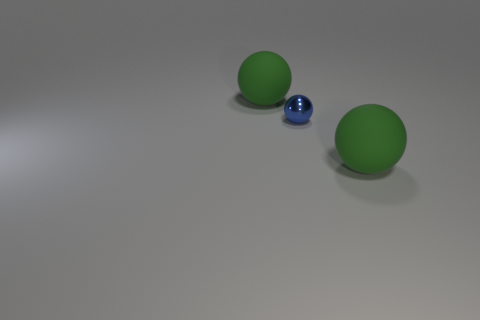Is there a big red cylinder made of the same material as the small thing?
Make the answer very short. No. What number of other objects are there of the same shape as the blue metallic object?
Your response must be concise. 2. How many objects are cyan cylinders or tiny blue spheres?
Offer a very short reply. 1. How many other things are the same size as the metallic ball?
Provide a short and direct response. 0. What number of balls are either big matte things or tiny objects?
Offer a terse response. 3. What is the tiny ball that is to the left of the green rubber ball that is in front of the small blue metal thing made of?
Your response must be concise. Metal. How many things are either big green matte balls that are on the left side of the small blue shiny sphere or tiny cyan metal blocks?
Your answer should be compact. 1. There is a blue object; is its shape the same as the matte object behind the blue thing?
Ensure brevity in your answer.  Yes. How many large green objects are behind the tiny sphere and in front of the small thing?
Provide a succinct answer. 0. There is a green rubber thing to the left of the big rubber sphere in front of the small metal object; what size is it?
Your answer should be very brief. Large. 